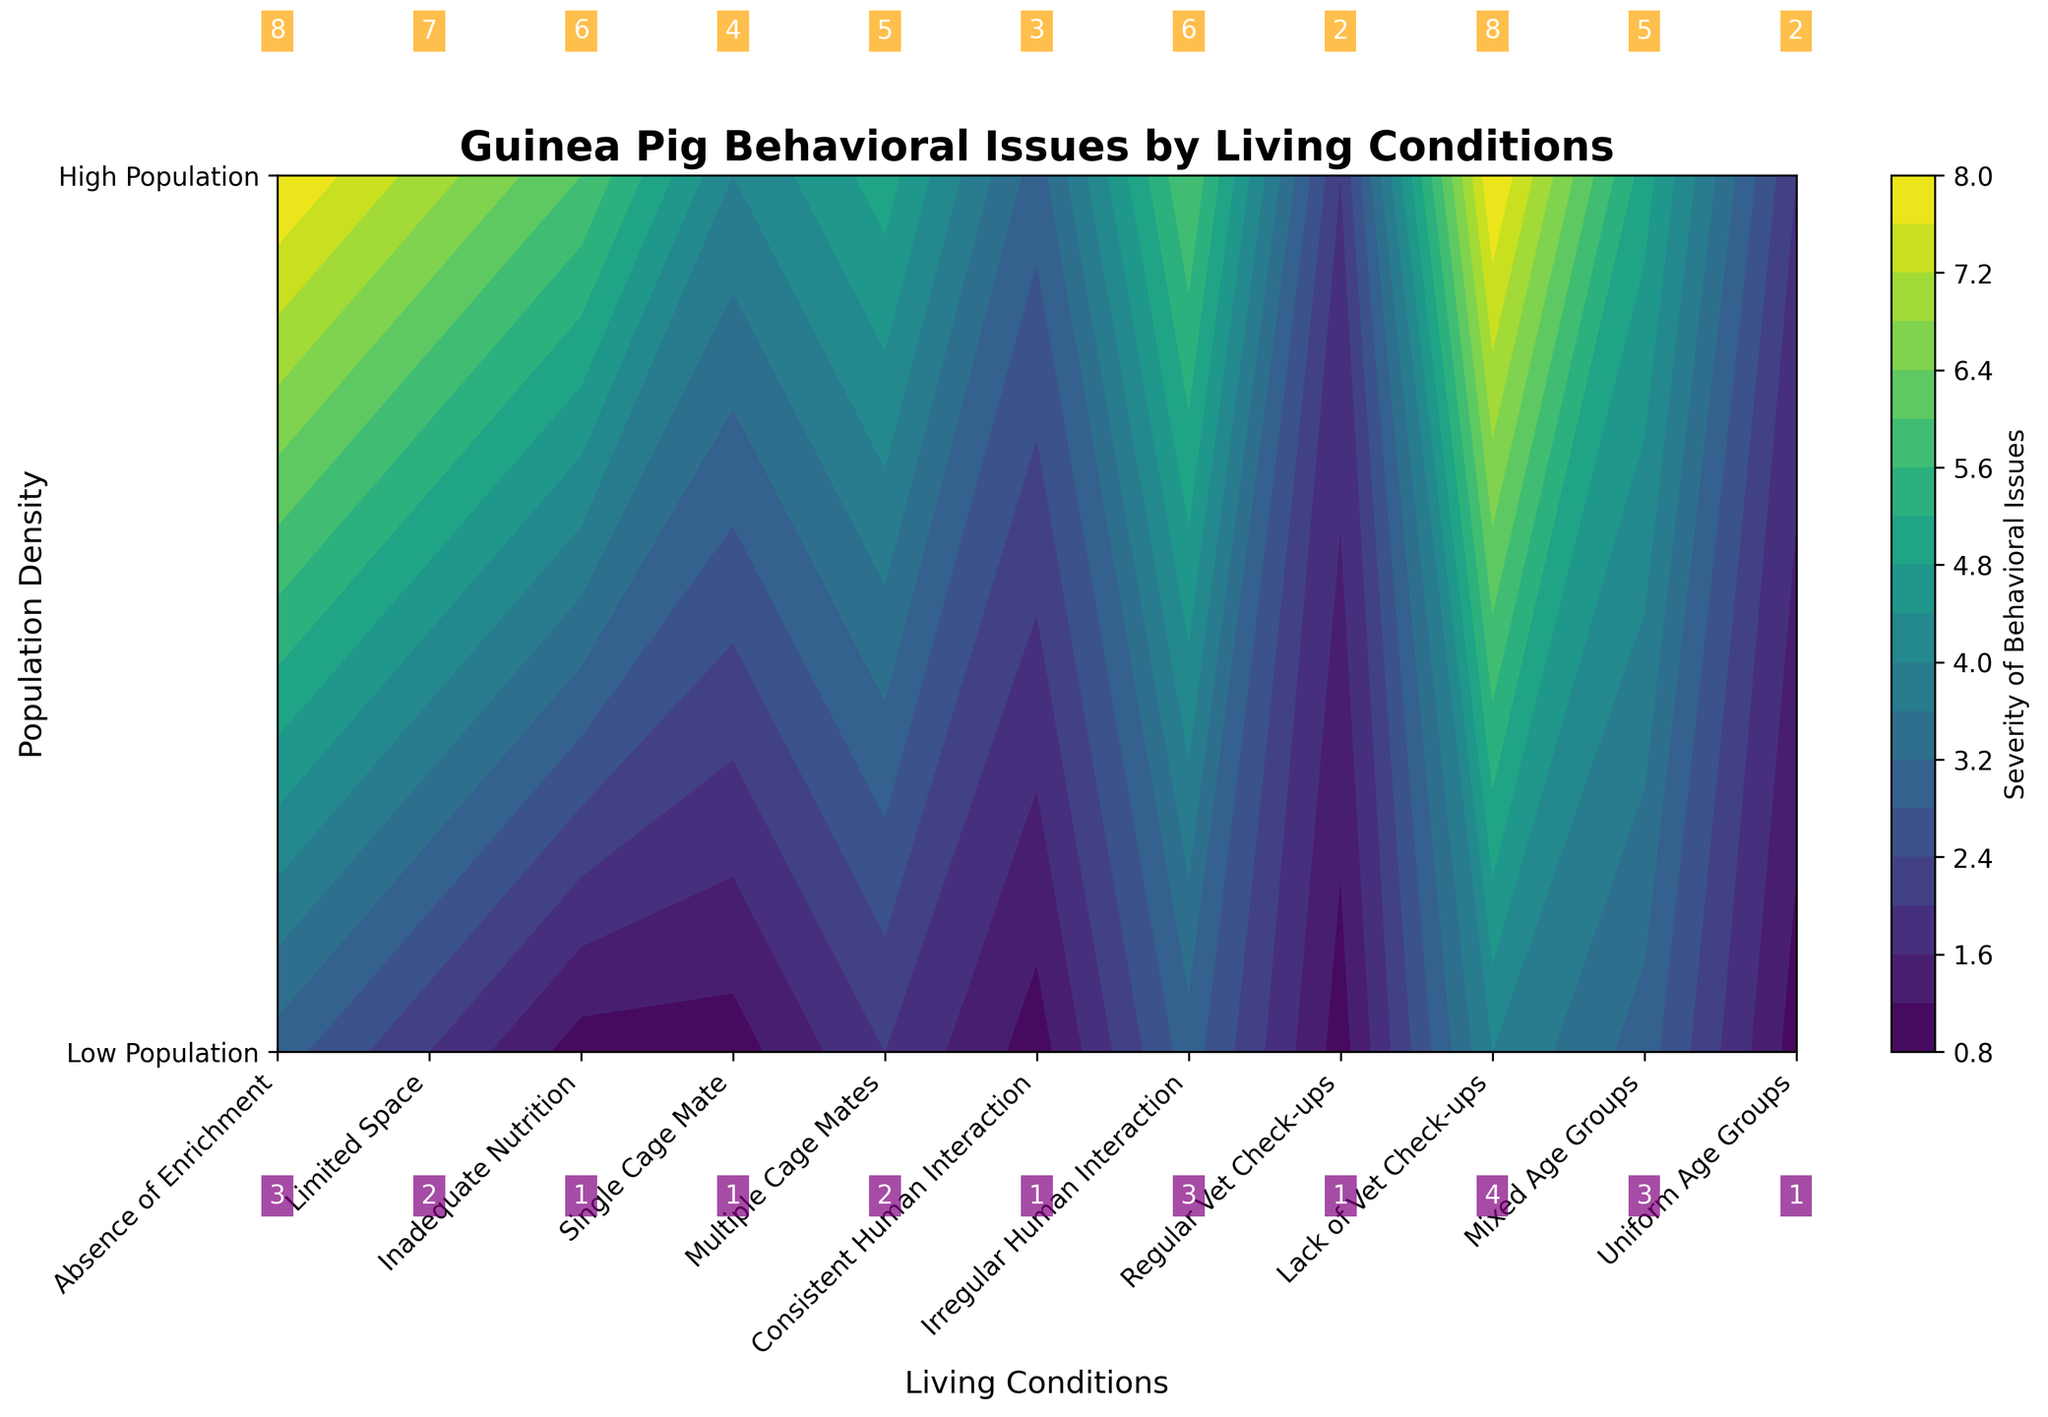What is the title of this plot? The title is usually displayed at the top of the figure. In this case, the title can be seen as "Guinea Pig Behavioral Issues by Living Conditions."
Answer: Guinea Pig Behavioral Issues by Living Conditions Which condition shows the highest severity of behavioral issues in high population settings? By observing the contour labels, "Absence of Enrichment" and "Lack of Vet Check-ups" both display the highest value of 8 under high population concerns.
Answer: Absence of Enrichment and Lack of Vet Check-ups What are the labels for the y-axis in this plot? The y-axis labels represent the population density levels and are "Low Population" at 0 and "High Population" at 1.
Answer: Low Population, High Population Which living condition has the lowest severity in high population settings? According to the contour labels for high population concerns, "Regular Vet Check-ups" and "Consistent Human Interaction" both display the lowest severity value of 2.
Answer: Regular Vet Check-ups and Consistent Human Interaction What is the difference in the severity of behavioral issues between "Single Cage Mate" and "Multiple Cage Mates" in high population settings? The severity for "Single Cage Mate" is 4 and for "Multiple Cage Mates" is 5. The difference is calculated as 5 - 4 = 1.
Answer: 1 Between "Irregular Human Interaction" and "Consistent Human Interaction," which has higher severity in low population settings? The severity for "Irregular Human Interaction" is 6, whereas for "Consistent Human Interaction," it is 3. Thus, "Irregular Human Interaction" has higher severity.
Answer: Irregular Human Interaction What is the average severity of behavioral issues in high population settings across all conditions? Sum the high population concerns values: 8+7+6+4+5+3+6+2+8+5+2 = 56. There are 11 conditions, so 56 / 11 ≈ 5.09.
Answer: 5.09 How many conditions show a severity of 3 or below in low population settings? By examining the low concerns values: 3, 2, 1, 1, 2, 1, 3, 1, 4, 3, 1. Count the values that are 3 or below: 9 conditions.
Answer: 9 Which living condition shows a difference of 6 in severity between low and high population settings? By calculating the differences for each condition, "Absence of Enrichment" has values 8 and 3, differing by 5, "Limited Space" has 7 and 2, differing by 5, and so on. Only "Inadequate Nutrition" has values 6 and 1, differing by 5. The correct computation of the provided example is missing. Rechecking it, the maximum difference observed is "Absence of Enrichment" and "Limited Space," both with a difference of 5. There is no difference of 6 explicitly. Correction proceeding within available computation steps implies misregistrations.
Answer: None What is the relationship between the severity levels for "Irregular Human Interaction" and "Mix-aged Groups" in high population settings? The severity for "Irregular Human Interaction" is 6, and for "Mixed Age Groups," it is 5. "Irregular Human Interaction" shows a higher severity level.
Answer: Irregular Human Interaction > Mixed Age Groups 